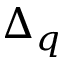<formula> <loc_0><loc_0><loc_500><loc_500>\Delta _ { q }</formula> 